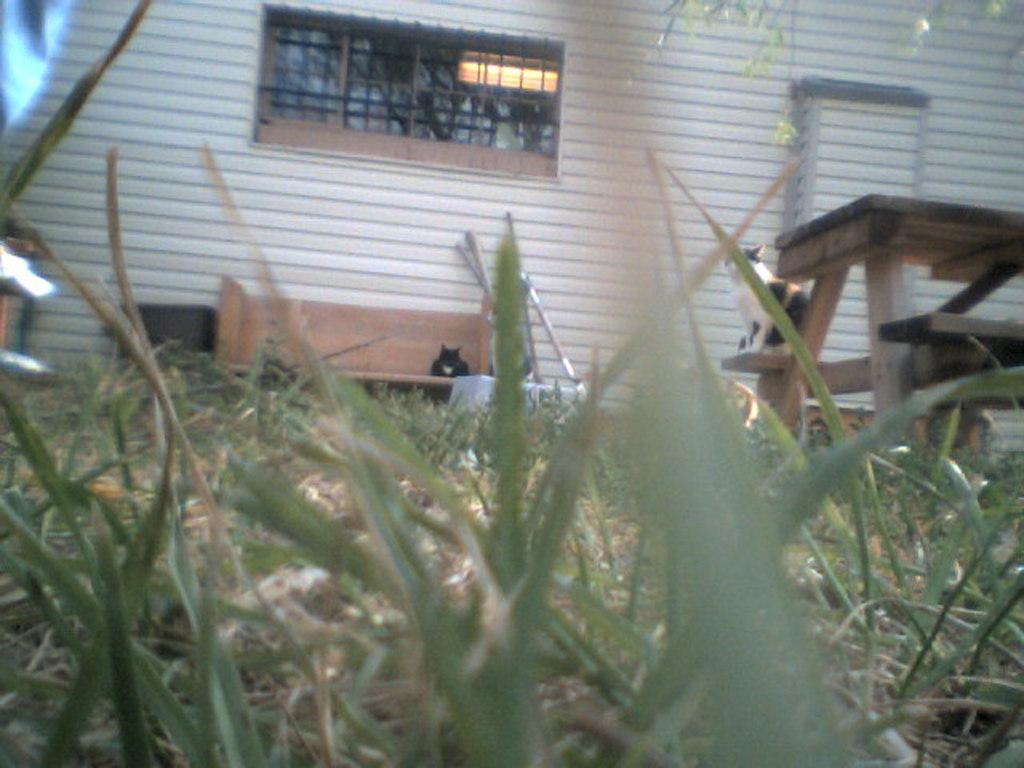Please provide a concise description of this image. In the foreground of this image, at the bottom there is a grass. On the right, there is a cat on the table. In the background, it seems like there is a cat on a bench, wall and a window. 